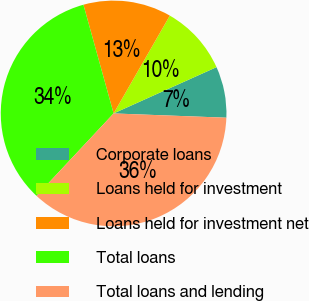Convert chart. <chart><loc_0><loc_0><loc_500><loc_500><pie_chart><fcel>Corporate loans<fcel>Loans held for investment<fcel>Loans held for investment net<fcel>Total loans<fcel>Total loans and lending<nl><fcel>7.33%<fcel>9.97%<fcel>12.61%<fcel>33.72%<fcel>36.36%<nl></chart> 